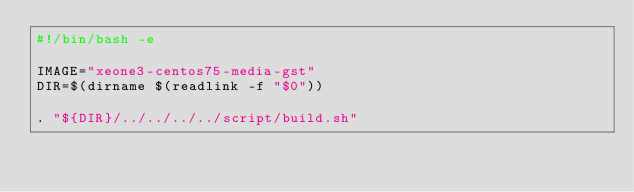Convert code to text. <code><loc_0><loc_0><loc_500><loc_500><_Bash_>#!/bin/bash -e

IMAGE="xeone3-centos75-media-gst"
DIR=$(dirname $(readlink -f "$0"))

. "${DIR}/../../../../script/build.sh"
</code> 